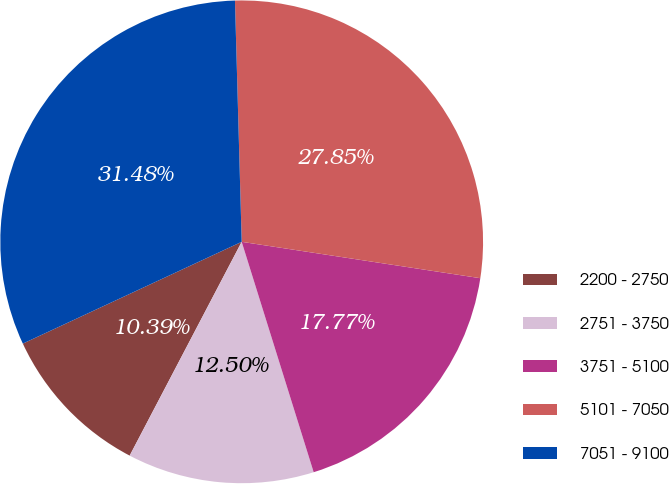<chart> <loc_0><loc_0><loc_500><loc_500><pie_chart><fcel>2200 - 2750<fcel>2751 - 3750<fcel>3751 - 5100<fcel>5101 - 7050<fcel>7051 - 9100<nl><fcel>10.39%<fcel>12.5%<fcel>17.77%<fcel>27.85%<fcel>31.48%<nl></chart> 